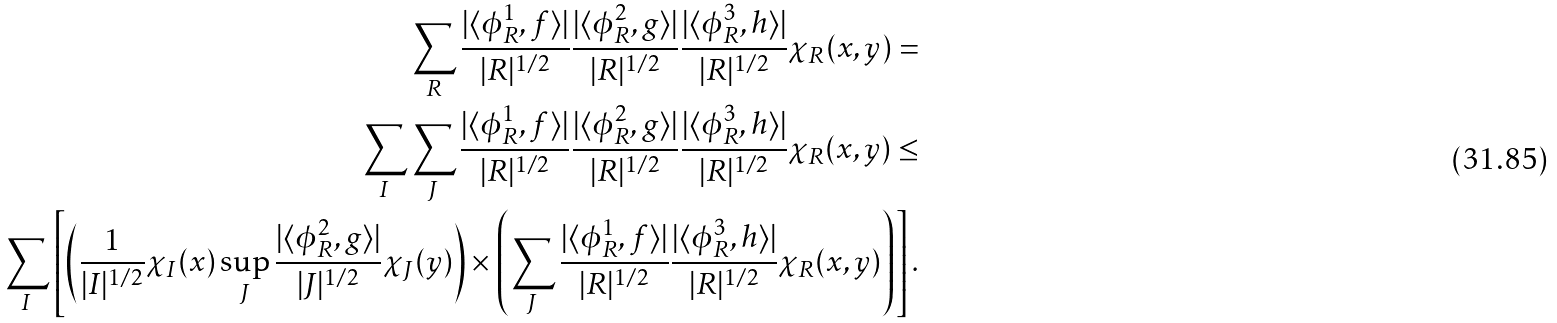<formula> <loc_0><loc_0><loc_500><loc_500>\sum _ { R } \frac { | \langle \phi ^ { 1 } _ { R } , f \rangle | } { | R | ^ { 1 / 2 } } \frac { | \langle \phi ^ { 2 } _ { R } , g \rangle | } { | R | ^ { 1 / 2 } } \frac { | \langle \phi ^ { 3 } _ { R } , h \rangle | } { | R | ^ { 1 / 2 } } \chi _ { R } ( x , y ) = \\ \sum _ { I } \sum _ { J } \frac { | \langle \phi ^ { 1 } _ { R } , f \rangle | } { | R | ^ { 1 / 2 } } \frac { | \langle \phi ^ { 2 } _ { R } , g \rangle | } { | R | ^ { 1 / 2 } } \frac { | \langle \phi ^ { 3 } _ { R } , h \rangle | } { | R | ^ { 1 / 2 } } \chi _ { R } ( x , y ) \leq \\ \sum _ { I } \left [ \left ( \frac { 1 } { | I | ^ { 1 / 2 } } \chi _ { I } ( x ) \sup _ { J } \frac { | \langle \phi ^ { 2 } _ { R } , g \rangle | } { | J | ^ { 1 / 2 } } \chi _ { J } ( y ) \right ) \times \left ( \sum _ { J } \frac { | \langle \phi ^ { 1 } _ { R } , f \rangle | } { | R | ^ { 1 / 2 } } \frac { | \langle \phi ^ { 3 } _ { R } , h \rangle | } { | R | ^ { 1 / 2 } } \chi _ { R } ( x , y ) \right ) \right ] .</formula> 